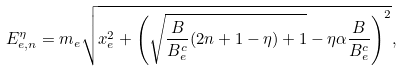Convert formula to latex. <formula><loc_0><loc_0><loc_500><loc_500>E _ { e , n } ^ { \eta } = m _ { e } \sqrt { x _ { e } ^ { 2 } + \left ( \sqrt { \frac { B } { B _ { e } ^ { c } } ( 2 n + 1 - \eta ) + 1 } - \eta \alpha \frac { B } { B _ { e } ^ { c } } \right ) ^ { 2 } } ,</formula> 